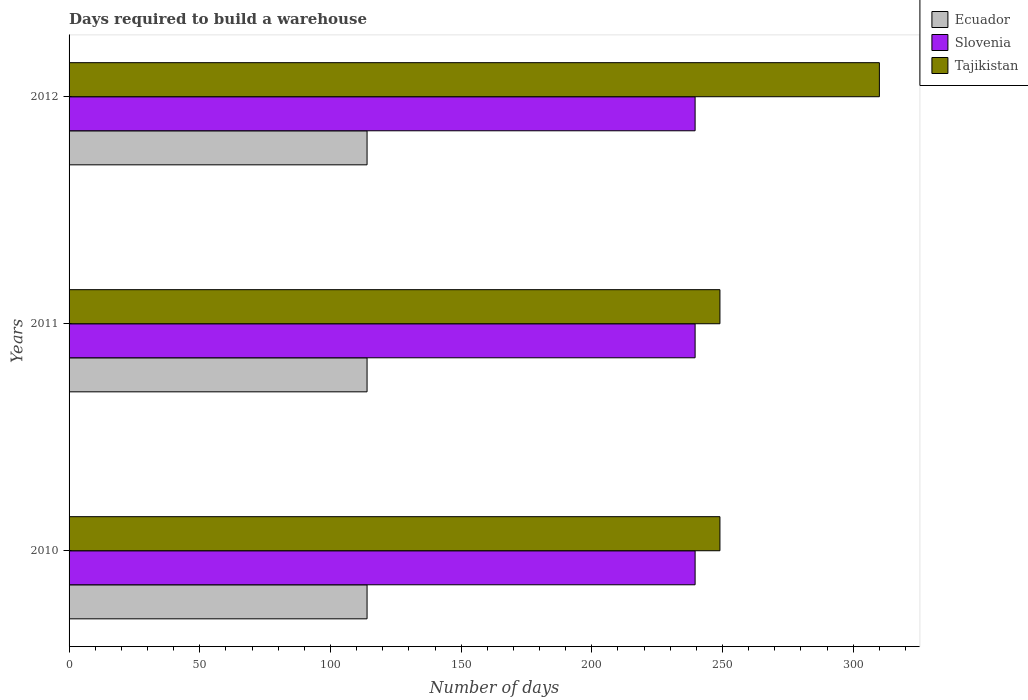How many groups of bars are there?
Your response must be concise. 3. Are the number of bars per tick equal to the number of legend labels?
Offer a very short reply. Yes. Are the number of bars on each tick of the Y-axis equal?
Make the answer very short. Yes. What is the days required to build a warehouse in in Slovenia in 2011?
Offer a terse response. 239.5. Across all years, what is the maximum days required to build a warehouse in in Ecuador?
Provide a short and direct response. 114. Across all years, what is the minimum days required to build a warehouse in in Slovenia?
Offer a very short reply. 239.5. In which year was the days required to build a warehouse in in Slovenia minimum?
Offer a very short reply. 2010. What is the total days required to build a warehouse in in Tajikistan in the graph?
Your answer should be very brief. 808. What is the difference between the days required to build a warehouse in in Tajikistan in 2010 and that in 2012?
Provide a succinct answer. -61. What is the difference between the days required to build a warehouse in in Tajikistan in 2011 and the days required to build a warehouse in in Ecuador in 2012?
Your response must be concise. 135. What is the average days required to build a warehouse in in Tajikistan per year?
Your response must be concise. 269.33. In the year 2012, what is the difference between the days required to build a warehouse in in Slovenia and days required to build a warehouse in in Tajikistan?
Ensure brevity in your answer.  -70.5. Is the difference between the days required to build a warehouse in in Slovenia in 2011 and 2012 greater than the difference between the days required to build a warehouse in in Tajikistan in 2011 and 2012?
Provide a short and direct response. Yes. What is the difference between the highest and the lowest days required to build a warehouse in in Slovenia?
Offer a terse response. 0. What does the 1st bar from the top in 2011 represents?
Your answer should be very brief. Tajikistan. What does the 1st bar from the bottom in 2011 represents?
Your response must be concise. Ecuador. Is it the case that in every year, the sum of the days required to build a warehouse in in Ecuador and days required to build a warehouse in in Slovenia is greater than the days required to build a warehouse in in Tajikistan?
Your response must be concise. Yes. Does the graph contain any zero values?
Provide a succinct answer. No. Where does the legend appear in the graph?
Provide a short and direct response. Top right. How many legend labels are there?
Provide a short and direct response. 3. How are the legend labels stacked?
Give a very brief answer. Vertical. What is the title of the graph?
Offer a very short reply. Days required to build a warehouse. What is the label or title of the X-axis?
Your response must be concise. Number of days. What is the Number of days in Ecuador in 2010?
Provide a succinct answer. 114. What is the Number of days in Slovenia in 2010?
Offer a very short reply. 239.5. What is the Number of days in Tajikistan in 2010?
Your answer should be compact. 249. What is the Number of days of Ecuador in 2011?
Ensure brevity in your answer.  114. What is the Number of days of Slovenia in 2011?
Ensure brevity in your answer.  239.5. What is the Number of days of Tajikistan in 2011?
Your answer should be very brief. 249. What is the Number of days of Ecuador in 2012?
Keep it short and to the point. 114. What is the Number of days in Slovenia in 2012?
Offer a very short reply. 239.5. What is the Number of days of Tajikistan in 2012?
Offer a very short reply. 310. Across all years, what is the maximum Number of days of Ecuador?
Make the answer very short. 114. Across all years, what is the maximum Number of days of Slovenia?
Your response must be concise. 239.5. Across all years, what is the maximum Number of days in Tajikistan?
Ensure brevity in your answer.  310. Across all years, what is the minimum Number of days of Ecuador?
Ensure brevity in your answer.  114. Across all years, what is the minimum Number of days of Slovenia?
Give a very brief answer. 239.5. Across all years, what is the minimum Number of days in Tajikistan?
Ensure brevity in your answer.  249. What is the total Number of days in Ecuador in the graph?
Provide a short and direct response. 342. What is the total Number of days in Slovenia in the graph?
Provide a succinct answer. 718.5. What is the total Number of days of Tajikistan in the graph?
Offer a terse response. 808. What is the difference between the Number of days of Ecuador in 2010 and that in 2011?
Offer a terse response. 0. What is the difference between the Number of days of Ecuador in 2010 and that in 2012?
Provide a succinct answer. 0. What is the difference between the Number of days of Slovenia in 2010 and that in 2012?
Provide a succinct answer. 0. What is the difference between the Number of days in Tajikistan in 2010 and that in 2012?
Ensure brevity in your answer.  -61. What is the difference between the Number of days of Ecuador in 2011 and that in 2012?
Offer a terse response. 0. What is the difference between the Number of days of Slovenia in 2011 and that in 2012?
Offer a terse response. 0. What is the difference between the Number of days of Tajikistan in 2011 and that in 2012?
Give a very brief answer. -61. What is the difference between the Number of days of Ecuador in 2010 and the Number of days of Slovenia in 2011?
Keep it short and to the point. -125.5. What is the difference between the Number of days in Ecuador in 2010 and the Number of days in Tajikistan in 2011?
Offer a terse response. -135. What is the difference between the Number of days of Ecuador in 2010 and the Number of days of Slovenia in 2012?
Give a very brief answer. -125.5. What is the difference between the Number of days in Ecuador in 2010 and the Number of days in Tajikistan in 2012?
Provide a short and direct response. -196. What is the difference between the Number of days in Slovenia in 2010 and the Number of days in Tajikistan in 2012?
Your response must be concise. -70.5. What is the difference between the Number of days of Ecuador in 2011 and the Number of days of Slovenia in 2012?
Your answer should be compact. -125.5. What is the difference between the Number of days of Ecuador in 2011 and the Number of days of Tajikistan in 2012?
Provide a short and direct response. -196. What is the difference between the Number of days of Slovenia in 2011 and the Number of days of Tajikistan in 2012?
Your answer should be compact. -70.5. What is the average Number of days in Ecuador per year?
Your response must be concise. 114. What is the average Number of days of Slovenia per year?
Offer a very short reply. 239.5. What is the average Number of days of Tajikistan per year?
Provide a succinct answer. 269.33. In the year 2010, what is the difference between the Number of days in Ecuador and Number of days in Slovenia?
Your answer should be very brief. -125.5. In the year 2010, what is the difference between the Number of days in Ecuador and Number of days in Tajikistan?
Offer a very short reply. -135. In the year 2010, what is the difference between the Number of days in Slovenia and Number of days in Tajikistan?
Offer a terse response. -9.5. In the year 2011, what is the difference between the Number of days of Ecuador and Number of days of Slovenia?
Make the answer very short. -125.5. In the year 2011, what is the difference between the Number of days of Ecuador and Number of days of Tajikistan?
Provide a succinct answer. -135. In the year 2011, what is the difference between the Number of days in Slovenia and Number of days in Tajikistan?
Offer a terse response. -9.5. In the year 2012, what is the difference between the Number of days of Ecuador and Number of days of Slovenia?
Provide a short and direct response. -125.5. In the year 2012, what is the difference between the Number of days of Ecuador and Number of days of Tajikistan?
Offer a terse response. -196. In the year 2012, what is the difference between the Number of days in Slovenia and Number of days in Tajikistan?
Give a very brief answer. -70.5. What is the ratio of the Number of days in Tajikistan in 2010 to that in 2012?
Give a very brief answer. 0.8. What is the ratio of the Number of days in Ecuador in 2011 to that in 2012?
Offer a terse response. 1. What is the ratio of the Number of days in Tajikistan in 2011 to that in 2012?
Offer a terse response. 0.8. What is the difference between the highest and the lowest Number of days in Ecuador?
Your response must be concise. 0. What is the difference between the highest and the lowest Number of days of Slovenia?
Your answer should be very brief. 0. What is the difference between the highest and the lowest Number of days of Tajikistan?
Keep it short and to the point. 61. 